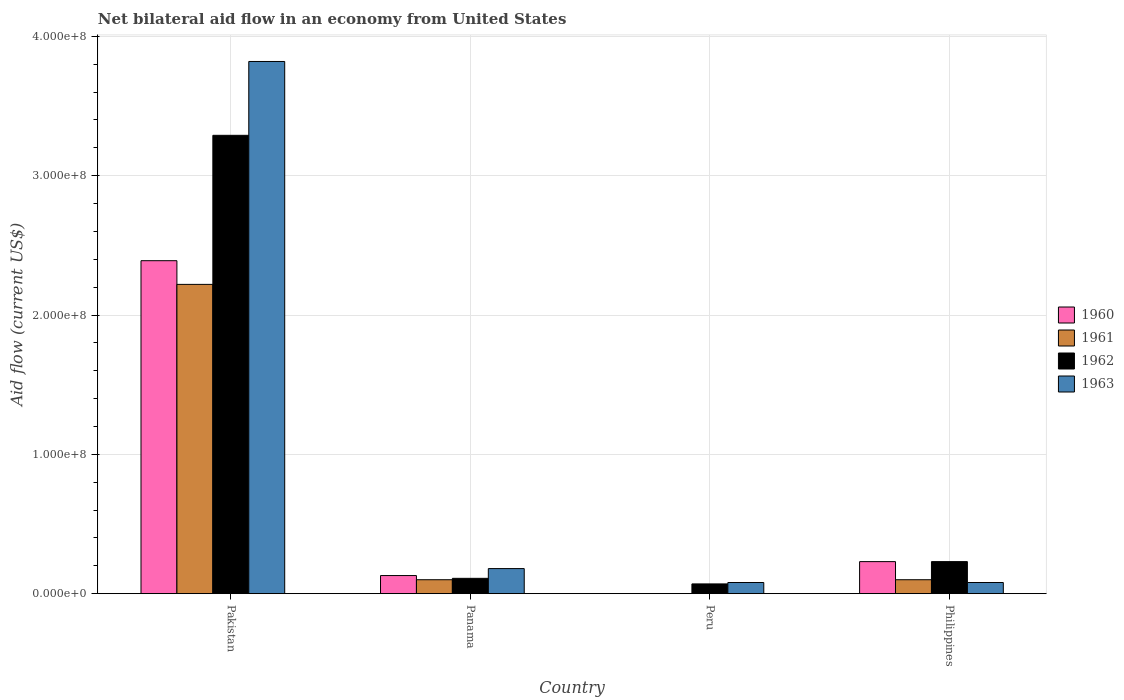How many different coloured bars are there?
Ensure brevity in your answer.  4. Are the number of bars on each tick of the X-axis equal?
Offer a terse response. No. How many bars are there on the 1st tick from the left?
Provide a short and direct response. 4. What is the label of the 3rd group of bars from the left?
Provide a succinct answer. Peru. What is the net bilateral aid flow in 1962 in Pakistan?
Keep it short and to the point. 3.29e+08. Across all countries, what is the maximum net bilateral aid flow in 1960?
Provide a short and direct response. 2.39e+08. What is the total net bilateral aid flow in 1960 in the graph?
Keep it short and to the point. 2.75e+08. What is the difference between the net bilateral aid flow in 1962 in Panama and that in Philippines?
Offer a terse response. -1.20e+07. What is the difference between the net bilateral aid flow in 1962 in Philippines and the net bilateral aid flow in 1960 in Pakistan?
Your answer should be compact. -2.16e+08. What is the average net bilateral aid flow in 1963 per country?
Provide a succinct answer. 1.04e+08. What is the difference between the net bilateral aid flow of/in 1963 and net bilateral aid flow of/in 1961 in Philippines?
Make the answer very short. -2.00e+06. In how many countries, is the net bilateral aid flow in 1963 greater than 140000000 US$?
Your response must be concise. 1. What is the ratio of the net bilateral aid flow in 1963 in Panama to that in Philippines?
Your response must be concise. 2.25. Is the difference between the net bilateral aid flow in 1963 in Pakistan and Philippines greater than the difference between the net bilateral aid flow in 1961 in Pakistan and Philippines?
Your response must be concise. Yes. What is the difference between the highest and the second highest net bilateral aid flow in 1962?
Your answer should be compact. 3.18e+08. What is the difference between the highest and the lowest net bilateral aid flow in 1963?
Your answer should be compact. 3.74e+08. In how many countries, is the net bilateral aid flow in 1963 greater than the average net bilateral aid flow in 1963 taken over all countries?
Provide a succinct answer. 1. How many bars are there?
Make the answer very short. 14. Are all the bars in the graph horizontal?
Keep it short and to the point. No. How many countries are there in the graph?
Provide a short and direct response. 4. What is the difference between two consecutive major ticks on the Y-axis?
Offer a very short reply. 1.00e+08. Does the graph contain any zero values?
Your answer should be compact. Yes. Where does the legend appear in the graph?
Give a very brief answer. Center right. How are the legend labels stacked?
Make the answer very short. Vertical. What is the title of the graph?
Your answer should be very brief. Net bilateral aid flow in an economy from United States. What is the label or title of the X-axis?
Your response must be concise. Country. What is the label or title of the Y-axis?
Keep it short and to the point. Aid flow (current US$). What is the Aid flow (current US$) in 1960 in Pakistan?
Offer a terse response. 2.39e+08. What is the Aid flow (current US$) of 1961 in Pakistan?
Your answer should be very brief. 2.22e+08. What is the Aid flow (current US$) of 1962 in Pakistan?
Give a very brief answer. 3.29e+08. What is the Aid flow (current US$) in 1963 in Pakistan?
Offer a very short reply. 3.82e+08. What is the Aid flow (current US$) in 1960 in Panama?
Ensure brevity in your answer.  1.30e+07. What is the Aid flow (current US$) of 1961 in Panama?
Give a very brief answer. 1.00e+07. What is the Aid flow (current US$) of 1962 in Panama?
Your response must be concise. 1.10e+07. What is the Aid flow (current US$) in 1963 in Panama?
Offer a terse response. 1.80e+07. What is the Aid flow (current US$) in 1962 in Peru?
Make the answer very short. 7.00e+06. What is the Aid flow (current US$) of 1963 in Peru?
Your answer should be very brief. 8.00e+06. What is the Aid flow (current US$) in 1960 in Philippines?
Your answer should be very brief. 2.30e+07. What is the Aid flow (current US$) of 1961 in Philippines?
Your answer should be compact. 1.00e+07. What is the Aid flow (current US$) in 1962 in Philippines?
Offer a very short reply. 2.30e+07. Across all countries, what is the maximum Aid flow (current US$) in 1960?
Offer a very short reply. 2.39e+08. Across all countries, what is the maximum Aid flow (current US$) in 1961?
Provide a succinct answer. 2.22e+08. Across all countries, what is the maximum Aid flow (current US$) of 1962?
Offer a very short reply. 3.29e+08. Across all countries, what is the maximum Aid flow (current US$) in 1963?
Give a very brief answer. 3.82e+08. Across all countries, what is the minimum Aid flow (current US$) in 1960?
Your answer should be compact. 0. Across all countries, what is the minimum Aid flow (current US$) in 1961?
Give a very brief answer. 0. What is the total Aid flow (current US$) of 1960 in the graph?
Your answer should be compact. 2.75e+08. What is the total Aid flow (current US$) in 1961 in the graph?
Give a very brief answer. 2.42e+08. What is the total Aid flow (current US$) of 1962 in the graph?
Make the answer very short. 3.70e+08. What is the total Aid flow (current US$) in 1963 in the graph?
Offer a very short reply. 4.16e+08. What is the difference between the Aid flow (current US$) of 1960 in Pakistan and that in Panama?
Your answer should be compact. 2.26e+08. What is the difference between the Aid flow (current US$) of 1961 in Pakistan and that in Panama?
Your response must be concise. 2.12e+08. What is the difference between the Aid flow (current US$) in 1962 in Pakistan and that in Panama?
Keep it short and to the point. 3.18e+08. What is the difference between the Aid flow (current US$) of 1963 in Pakistan and that in Panama?
Provide a succinct answer. 3.64e+08. What is the difference between the Aid flow (current US$) of 1962 in Pakistan and that in Peru?
Make the answer very short. 3.22e+08. What is the difference between the Aid flow (current US$) of 1963 in Pakistan and that in Peru?
Make the answer very short. 3.74e+08. What is the difference between the Aid flow (current US$) in 1960 in Pakistan and that in Philippines?
Ensure brevity in your answer.  2.16e+08. What is the difference between the Aid flow (current US$) in 1961 in Pakistan and that in Philippines?
Keep it short and to the point. 2.12e+08. What is the difference between the Aid flow (current US$) in 1962 in Pakistan and that in Philippines?
Keep it short and to the point. 3.06e+08. What is the difference between the Aid flow (current US$) in 1963 in Pakistan and that in Philippines?
Your answer should be very brief. 3.74e+08. What is the difference between the Aid flow (current US$) of 1962 in Panama and that in Peru?
Give a very brief answer. 4.00e+06. What is the difference between the Aid flow (current US$) in 1960 in Panama and that in Philippines?
Your answer should be compact. -1.00e+07. What is the difference between the Aid flow (current US$) in 1962 in Panama and that in Philippines?
Offer a very short reply. -1.20e+07. What is the difference between the Aid flow (current US$) in 1962 in Peru and that in Philippines?
Keep it short and to the point. -1.60e+07. What is the difference between the Aid flow (current US$) in 1960 in Pakistan and the Aid flow (current US$) in 1961 in Panama?
Give a very brief answer. 2.29e+08. What is the difference between the Aid flow (current US$) of 1960 in Pakistan and the Aid flow (current US$) of 1962 in Panama?
Provide a succinct answer. 2.28e+08. What is the difference between the Aid flow (current US$) in 1960 in Pakistan and the Aid flow (current US$) in 1963 in Panama?
Offer a terse response. 2.21e+08. What is the difference between the Aid flow (current US$) of 1961 in Pakistan and the Aid flow (current US$) of 1962 in Panama?
Make the answer very short. 2.11e+08. What is the difference between the Aid flow (current US$) in 1961 in Pakistan and the Aid flow (current US$) in 1963 in Panama?
Your answer should be compact. 2.04e+08. What is the difference between the Aid flow (current US$) of 1962 in Pakistan and the Aid flow (current US$) of 1963 in Panama?
Provide a succinct answer. 3.11e+08. What is the difference between the Aid flow (current US$) in 1960 in Pakistan and the Aid flow (current US$) in 1962 in Peru?
Your response must be concise. 2.32e+08. What is the difference between the Aid flow (current US$) of 1960 in Pakistan and the Aid flow (current US$) of 1963 in Peru?
Keep it short and to the point. 2.31e+08. What is the difference between the Aid flow (current US$) of 1961 in Pakistan and the Aid flow (current US$) of 1962 in Peru?
Keep it short and to the point. 2.15e+08. What is the difference between the Aid flow (current US$) in 1961 in Pakistan and the Aid flow (current US$) in 1963 in Peru?
Provide a short and direct response. 2.14e+08. What is the difference between the Aid flow (current US$) in 1962 in Pakistan and the Aid flow (current US$) in 1963 in Peru?
Ensure brevity in your answer.  3.21e+08. What is the difference between the Aid flow (current US$) in 1960 in Pakistan and the Aid flow (current US$) in 1961 in Philippines?
Your response must be concise. 2.29e+08. What is the difference between the Aid flow (current US$) of 1960 in Pakistan and the Aid flow (current US$) of 1962 in Philippines?
Your answer should be very brief. 2.16e+08. What is the difference between the Aid flow (current US$) of 1960 in Pakistan and the Aid flow (current US$) of 1963 in Philippines?
Ensure brevity in your answer.  2.31e+08. What is the difference between the Aid flow (current US$) in 1961 in Pakistan and the Aid flow (current US$) in 1962 in Philippines?
Make the answer very short. 1.99e+08. What is the difference between the Aid flow (current US$) of 1961 in Pakistan and the Aid flow (current US$) of 1963 in Philippines?
Make the answer very short. 2.14e+08. What is the difference between the Aid flow (current US$) in 1962 in Pakistan and the Aid flow (current US$) in 1963 in Philippines?
Provide a short and direct response. 3.21e+08. What is the difference between the Aid flow (current US$) of 1960 in Panama and the Aid flow (current US$) of 1962 in Peru?
Your answer should be very brief. 6.00e+06. What is the difference between the Aid flow (current US$) of 1960 in Panama and the Aid flow (current US$) of 1961 in Philippines?
Ensure brevity in your answer.  3.00e+06. What is the difference between the Aid flow (current US$) in 1960 in Panama and the Aid flow (current US$) in 1962 in Philippines?
Your answer should be very brief. -1.00e+07. What is the difference between the Aid flow (current US$) of 1961 in Panama and the Aid flow (current US$) of 1962 in Philippines?
Provide a succinct answer. -1.30e+07. What is the difference between the Aid flow (current US$) of 1961 in Panama and the Aid flow (current US$) of 1963 in Philippines?
Provide a succinct answer. 2.00e+06. What is the difference between the Aid flow (current US$) in 1962 in Panama and the Aid flow (current US$) in 1963 in Philippines?
Your response must be concise. 3.00e+06. What is the difference between the Aid flow (current US$) in 1962 in Peru and the Aid flow (current US$) in 1963 in Philippines?
Give a very brief answer. -1.00e+06. What is the average Aid flow (current US$) in 1960 per country?
Your answer should be very brief. 6.88e+07. What is the average Aid flow (current US$) of 1961 per country?
Your answer should be compact. 6.05e+07. What is the average Aid flow (current US$) of 1962 per country?
Offer a very short reply. 9.25e+07. What is the average Aid flow (current US$) in 1963 per country?
Offer a terse response. 1.04e+08. What is the difference between the Aid flow (current US$) in 1960 and Aid flow (current US$) in 1961 in Pakistan?
Provide a short and direct response. 1.70e+07. What is the difference between the Aid flow (current US$) in 1960 and Aid flow (current US$) in 1962 in Pakistan?
Your answer should be very brief. -9.00e+07. What is the difference between the Aid flow (current US$) of 1960 and Aid flow (current US$) of 1963 in Pakistan?
Offer a very short reply. -1.43e+08. What is the difference between the Aid flow (current US$) of 1961 and Aid flow (current US$) of 1962 in Pakistan?
Provide a succinct answer. -1.07e+08. What is the difference between the Aid flow (current US$) in 1961 and Aid flow (current US$) in 1963 in Pakistan?
Keep it short and to the point. -1.60e+08. What is the difference between the Aid flow (current US$) in 1962 and Aid flow (current US$) in 1963 in Pakistan?
Your response must be concise. -5.30e+07. What is the difference between the Aid flow (current US$) in 1960 and Aid flow (current US$) in 1961 in Panama?
Ensure brevity in your answer.  3.00e+06. What is the difference between the Aid flow (current US$) of 1960 and Aid flow (current US$) of 1962 in Panama?
Offer a terse response. 2.00e+06. What is the difference between the Aid flow (current US$) in 1960 and Aid flow (current US$) in 1963 in Panama?
Your answer should be compact. -5.00e+06. What is the difference between the Aid flow (current US$) in 1961 and Aid flow (current US$) in 1962 in Panama?
Provide a short and direct response. -1.00e+06. What is the difference between the Aid flow (current US$) of 1961 and Aid flow (current US$) of 1963 in Panama?
Ensure brevity in your answer.  -8.00e+06. What is the difference between the Aid flow (current US$) in 1962 and Aid flow (current US$) in 1963 in Panama?
Keep it short and to the point. -7.00e+06. What is the difference between the Aid flow (current US$) of 1960 and Aid flow (current US$) of 1961 in Philippines?
Ensure brevity in your answer.  1.30e+07. What is the difference between the Aid flow (current US$) of 1960 and Aid flow (current US$) of 1962 in Philippines?
Provide a succinct answer. 0. What is the difference between the Aid flow (current US$) in 1960 and Aid flow (current US$) in 1963 in Philippines?
Your answer should be very brief. 1.50e+07. What is the difference between the Aid flow (current US$) in 1961 and Aid flow (current US$) in 1962 in Philippines?
Give a very brief answer. -1.30e+07. What is the difference between the Aid flow (current US$) in 1961 and Aid flow (current US$) in 1963 in Philippines?
Provide a succinct answer. 2.00e+06. What is the difference between the Aid flow (current US$) of 1962 and Aid flow (current US$) of 1963 in Philippines?
Keep it short and to the point. 1.50e+07. What is the ratio of the Aid flow (current US$) of 1960 in Pakistan to that in Panama?
Your response must be concise. 18.38. What is the ratio of the Aid flow (current US$) in 1961 in Pakistan to that in Panama?
Provide a short and direct response. 22.2. What is the ratio of the Aid flow (current US$) of 1962 in Pakistan to that in Panama?
Ensure brevity in your answer.  29.91. What is the ratio of the Aid flow (current US$) of 1963 in Pakistan to that in Panama?
Offer a terse response. 21.22. What is the ratio of the Aid flow (current US$) in 1962 in Pakistan to that in Peru?
Offer a terse response. 47. What is the ratio of the Aid flow (current US$) of 1963 in Pakistan to that in Peru?
Ensure brevity in your answer.  47.75. What is the ratio of the Aid flow (current US$) in 1960 in Pakistan to that in Philippines?
Your answer should be compact. 10.39. What is the ratio of the Aid flow (current US$) in 1961 in Pakistan to that in Philippines?
Provide a succinct answer. 22.2. What is the ratio of the Aid flow (current US$) in 1962 in Pakistan to that in Philippines?
Give a very brief answer. 14.3. What is the ratio of the Aid flow (current US$) of 1963 in Pakistan to that in Philippines?
Provide a short and direct response. 47.75. What is the ratio of the Aid flow (current US$) in 1962 in Panama to that in Peru?
Ensure brevity in your answer.  1.57. What is the ratio of the Aid flow (current US$) in 1963 in Panama to that in Peru?
Keep it short and to the point. 2.25. What is the ratio of the Aid flow (current US$) in 1960 in Panama to that in Philippines?
Provide a succinct answer. 0.57. What is the ratio of the Aid flow (current US$) of 1961 in Panama to that in Philippines?
Make the answer very short. 1. What is the ratio of the Aid flow (current US$) of 1962 in Panama to that in Philippines?
Give a very brief answer. 0.48. What is the ratio of the Aid flow (current US$) in 1963 in Panama to that in Philippines?
Provide a short and direct response. 2.25. What is the ratio of the Aid flow (current US$) in 1962 in Peru to that in Philippines?
Give a very brief answer. 0.3. What is the difference between the highest and the second highest Aid flow (current US$) of 1960?
Provide a short and direct response. 2.16e+08. What is the difference between the highest and the second highest Aid flow (current US$) in 1961?
Provide a short and direct response. 2.12e+08. What is the difference between the highest and the second highest Aid flow (current US$) in 1962?
Provide a short and direct response. 3.06e+08. What is the difference between the highest and the second highest Aid flow (current US$) in 1963?
Make the answer very short. 3.64e+08. What is the difference between the highest and the lowest Aid flow (current US$) of 1960?
Offer a very short reply. 2.39e+08. What is the difference between the highest and the lowest Aid flow (current US$) of 1961?
Ensure brevity in your answer.  2.22e+08. What is the difference between the highest and the lowest Aid flow (current US$) of 1962?
Ensure brevity in your answer.  3.22e+08. What is the difference between the highest and the lowest Aid flow (current US$) of 1963?
Offer a very short reply. 3.74e+08. 